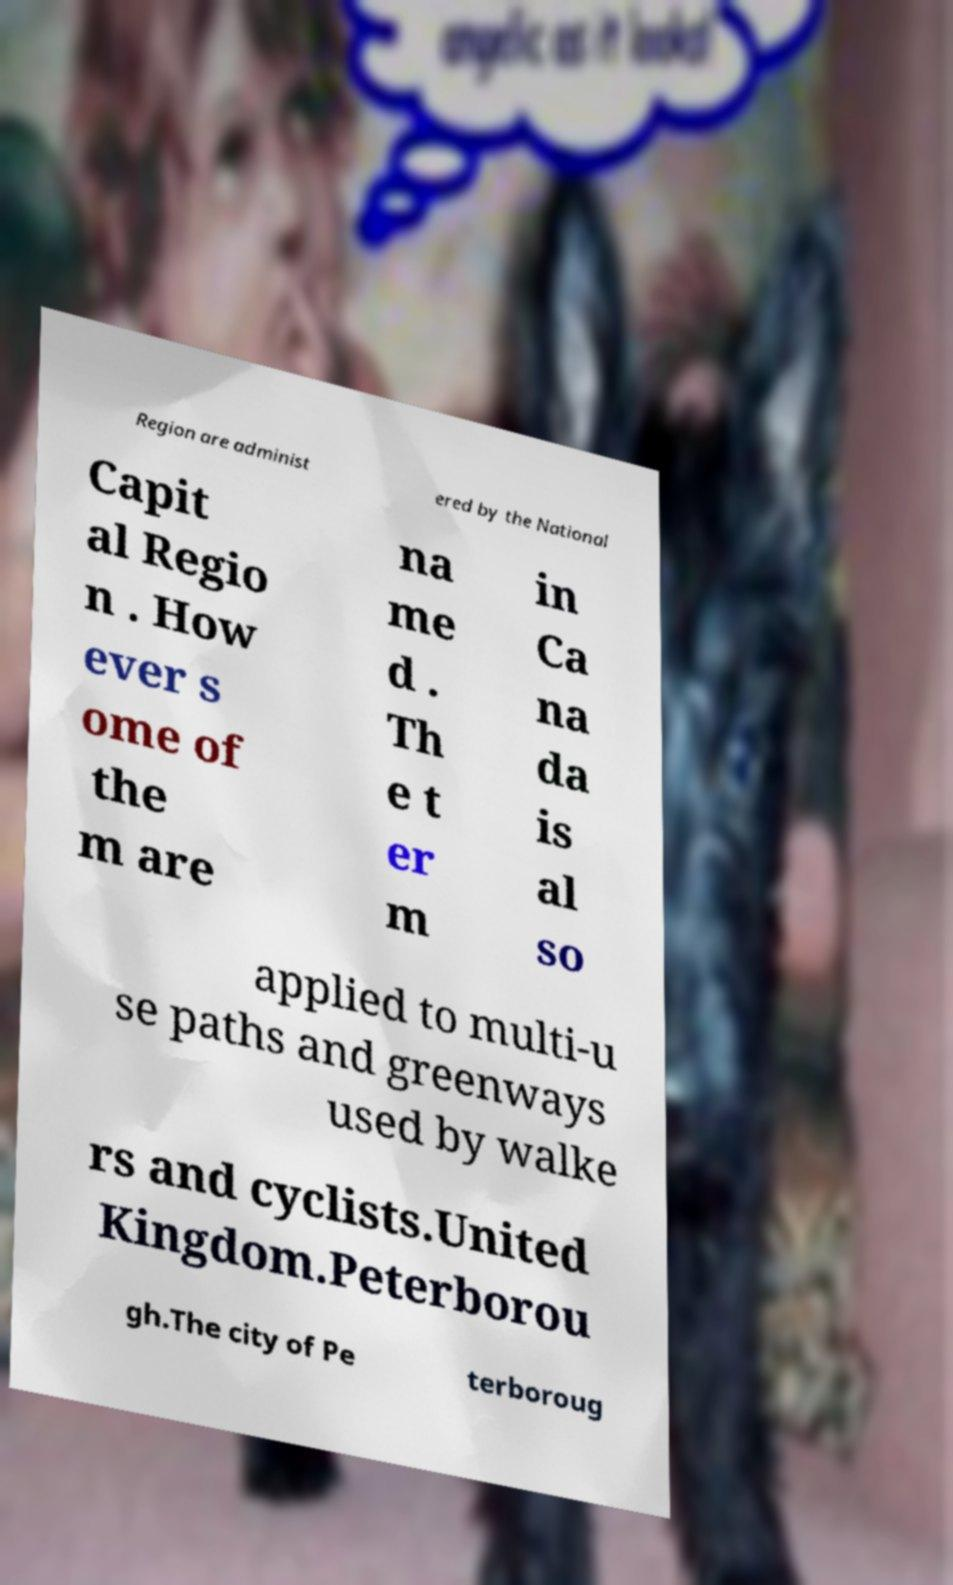I need the written content from this picture converted into text. Can you do that? Region are administ ered by the National Capit al Regio n . How ever s ome of the m are na me d . Th e t er m in Ca na da is al so applied to multi-u se paths and greenways used by walke rs and cyclists.United Kingdom.Peterborou gh.The city of Pe terboroug 